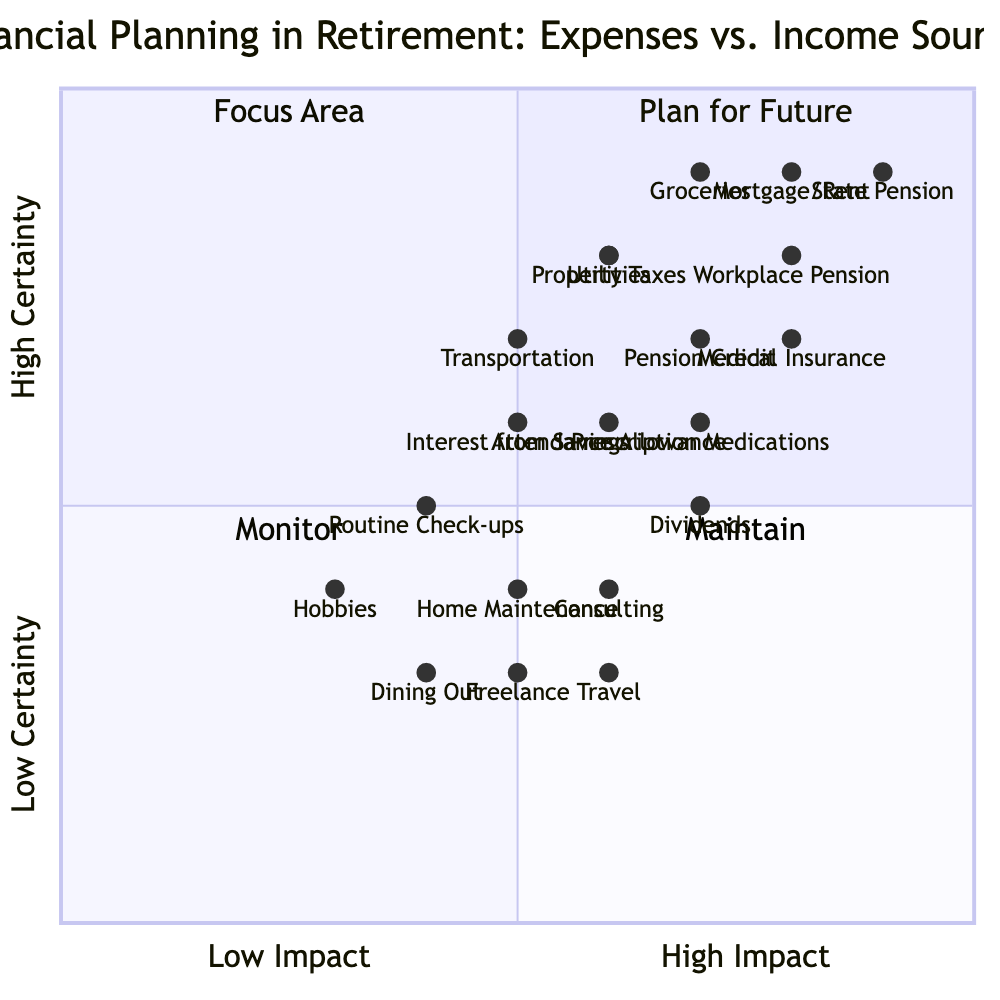What is the impact level of "Medical Insurance"? The diagram shows "Medical Insurance" is placed at coordinates [0.8, 0.7]. The x-coordinate (0.8) indicates a high impact level, while the y-coordinate (0.7) suggests a relatively high certainty.
Answer: 0.8 How many income sources fall into the "Plan for Future" quadrant? In the "Plan for Future" quadrant, the relevant income sources are "State Pension" at [0.9, 0.9] and "Workplace Pension" at [0.8, 0.8]. That makes a total of 2.
Answer: 2 Which expense has the lowest certainty? The expense "Dining Out" is located at [0.4, 0.3], which indicates it has the lowest y-value (certainty) compared to other expenses in the chart.
Answer: Dining Out What is the average impact level of the leisure activities shown? The leisure activities listed are "Travel" at [0.6, 0.3], "Hobbies" at [0.3, 0.4], and "Dining Out" at [0.4, 0.3]. The average impact is calculated as (0.6 + 0.3 + 0.4) / 3 = 0.433.
Answer: 0.433 Which income source lies in the "Maintain" quadrant? The income sources "Dividends" at [0.7, 0.5] and "Pension Credit" at [0.7, 0.7] both lie in the "Maintain" quadrant, as both have a lower impact and varying degrees of certainty.
Answer: Dividends, Pension Credit How many expenses fall into the "Focus Area" quadrant? The expenses in the "Focus Area" quadrant include "Mortgage/Rent" at [0.8, 0.9], "Groceries" at [0.7, 0.9], and "Medical Insurance" at [0.8, 0.7]. This totals to 3 expenses.
Answer: 3 Which expense has a higher certainty: "Utilities" or "Transportation"? "Utilities" is positioned at [0.6, 0.8] while "Transportation" is at [0.5, 0.7]. The y-coordinate represents certainty, making "Utilities" with a value of 0.8 higher than "Transportation" with 0.7.
Answer: Utilities What is the relationship between "Property Taxes" and "Mortgage/Rent"? "Mortgage/Rent" is at [0.8, 0.9] indicating a higher impact and certainty than "Property Taxes" which is at [0.6, 0.8]. The relationship shows that "Mortgage/Rent" is prioritized due to its higher impact.
Answer: Mortgage/Rent is prioritized Which income source is located closest to the lowest impact in the income sources quadrant? The income source "Interest from Savings" is located at [0.5, 0.6], which is closest to the lowest impact as it has the lowest x-coordinate among the income sources.
Answer: Interest from Savings 